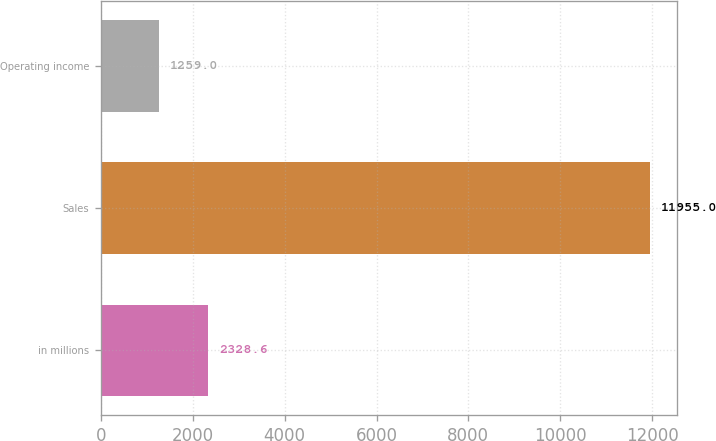Convert chart to OTSL. <chart><loc_0><loc_0><loc_500><loc_500><bar_chart><fcel>in millions<fcel>Sales<fcel>Operating income<nl><fcel>2328.6<fcel>11955<fcel>1259<nl></chart> 